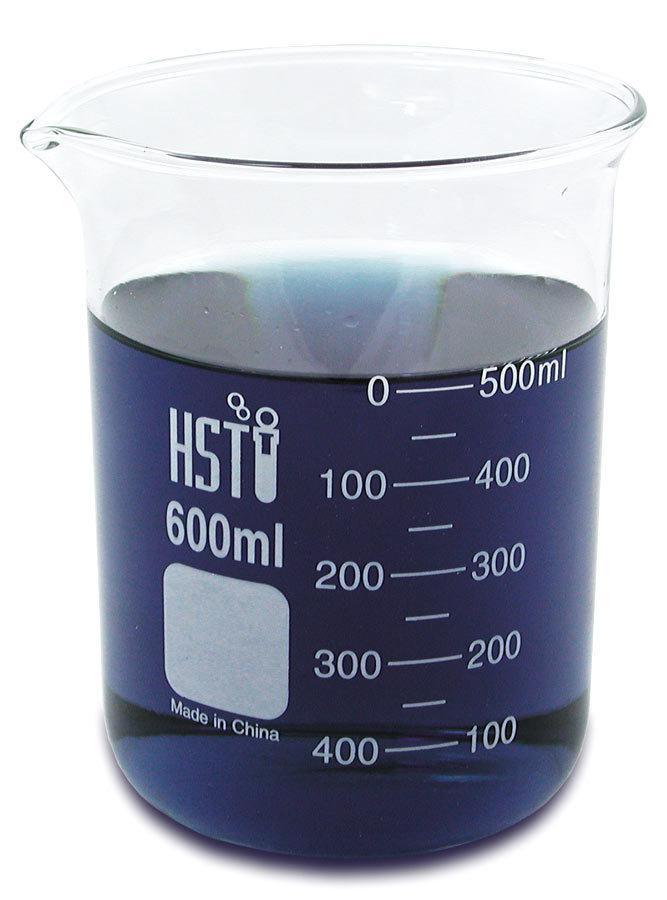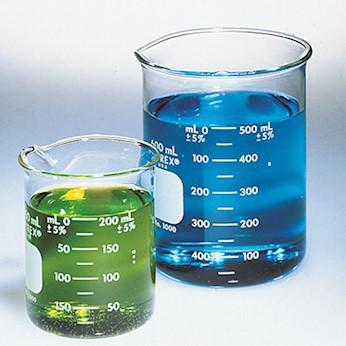The first image is the image on the left, the second image is the image on the right. Evaluate the accuracy of this statement regarding the images: "One beaker is filled with blue liquid, and one beaker is filled with reddish liquid.". Is it true? Answer yes or no. No. The first image is the image on the left, the second image is the image on the right. Considering the images on both sides, is "The left and right image contains the same number of full beakers." valid? Answer yes or no. No. 